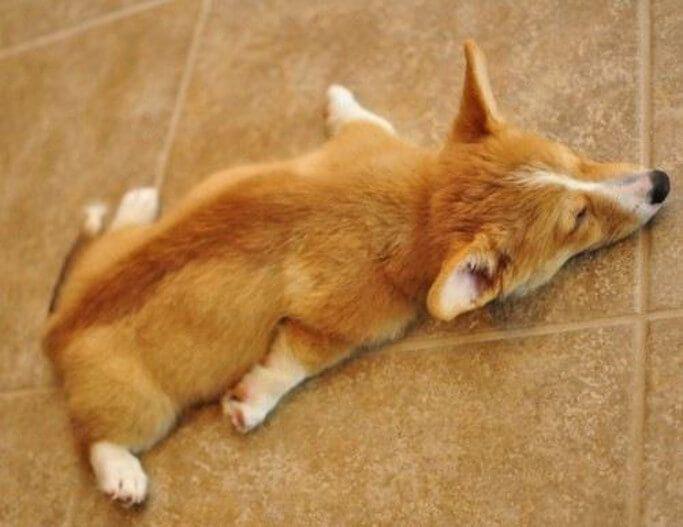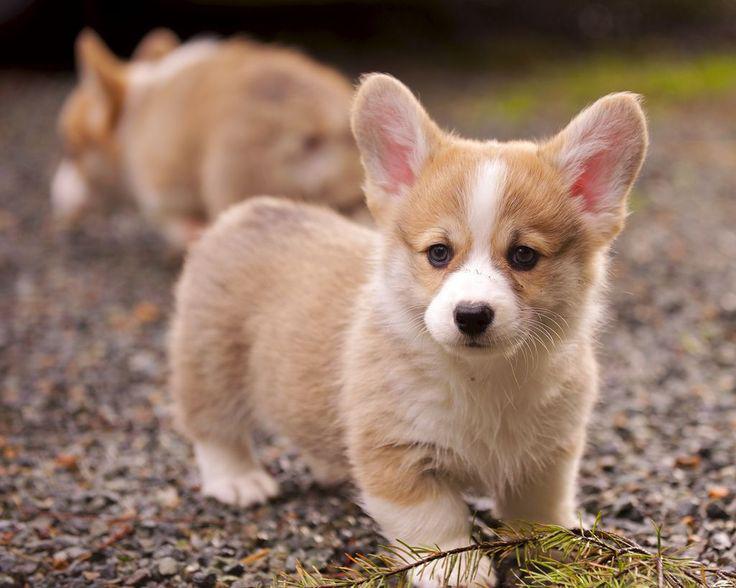The first image is the image on the left, the second image is the image on the right. For the images shown, is this caption "There are three dogs." true? Answer yes or no. Yes. The first image is the image on the left, the second image is the image on the right. Considering the images on both sides, is "One image contains twice as many dogs as the other image and includes a dog standing on all fours facing forward." valid? Answer yes or no. Yes. 